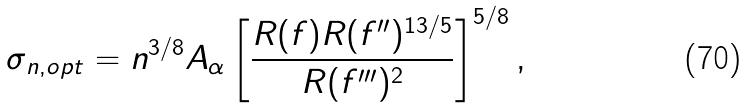<formula> <loc_0><loc_0><loc_500><loc_500>\sigma _ { n , o p t } = n ^ { 3 / 8 } A _ { \alpha } \left [ \frac { R ( f ) R ( f ^ { \prime \prime } ) ^ { 1 3 / 5 } } { R ( f ^ { \prime \prime \prime } ) ^ { 2 } } \right ] ^ { 5 / 8 } ,</formula> 